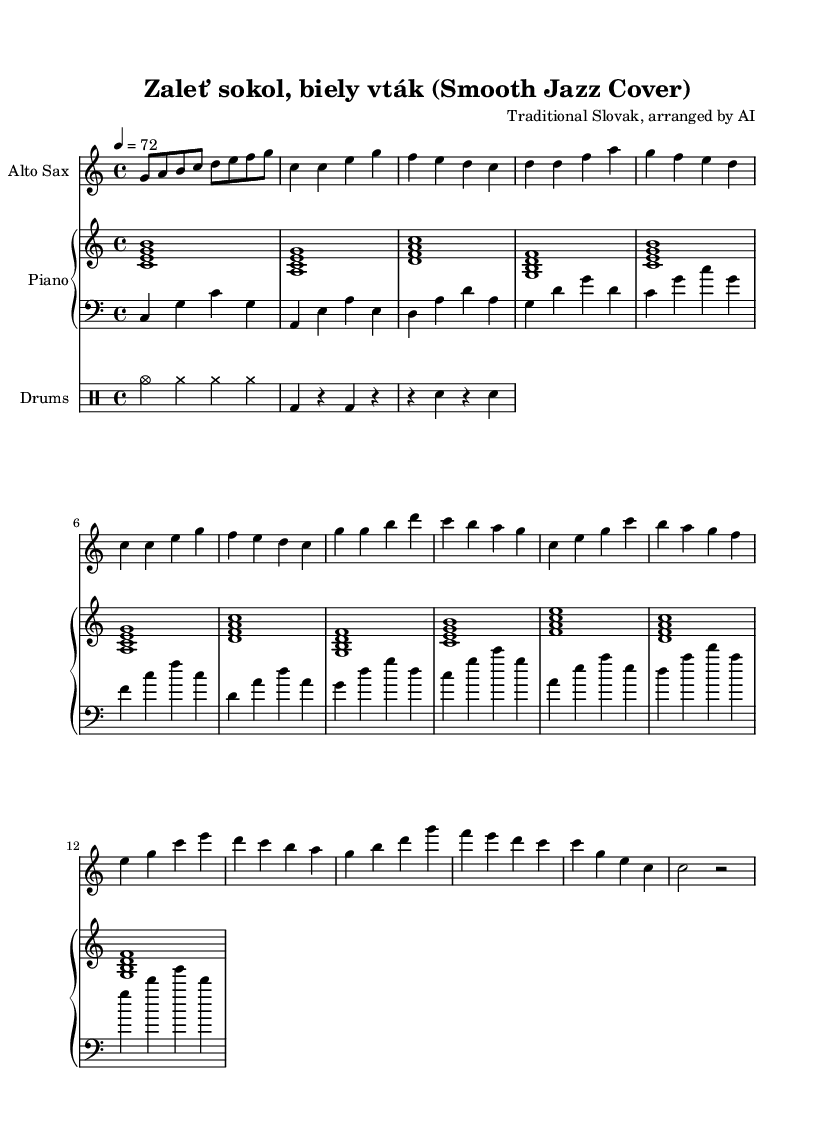What is the key signature of this music? The key signature is indicated by the number of sharps or flats at the beginning of the staff. In this score, there are no sharps or flats, which means it is in the key of C major.
Answer: C major What is the time signature of this music? The time signature is displayed as a fraction at the beginning of the staff. Here, it is shown as 4/4, meaning there are four beats in a measure and the quarter note gets one beat.
Answer: 4/4 What is the tempo marking for this piece? The tempo is indicated by a number followed by the word "equals" at the beginning of the score. In this case, it shows 4 equals 72, meaning there are 72 beats per minute.
Answer: 72 How many measures are in the saxophone part? To find the number of measures, count the number of distinct sets of bars (vertical lines) in the saxophone part. There are 8 measures visible in the saxophone section.
Answer: 8 What is the primary instrument featured in this arrangement? The main instrument is indicated through the title of the staff. The score shows "Alto Sax" at the top of the saxophone staff, indicating that the alto saxophone is the primary instrument.
Answer: Alto Sax Which section features the highest notes played? The highest notes can generally be identified by looking at the pitch of the notes in each section. In the saxophone part, the notes reach higher pitches during the chorus, particularly when the notes g and b are played.
Answer: Chorus What is the initial chord played by the piano? The initial chords of each section are indicated by the combinations of notes played. The first chord in the piano part is a C major chord comprising c, e, and g.
Answer: C major chord 